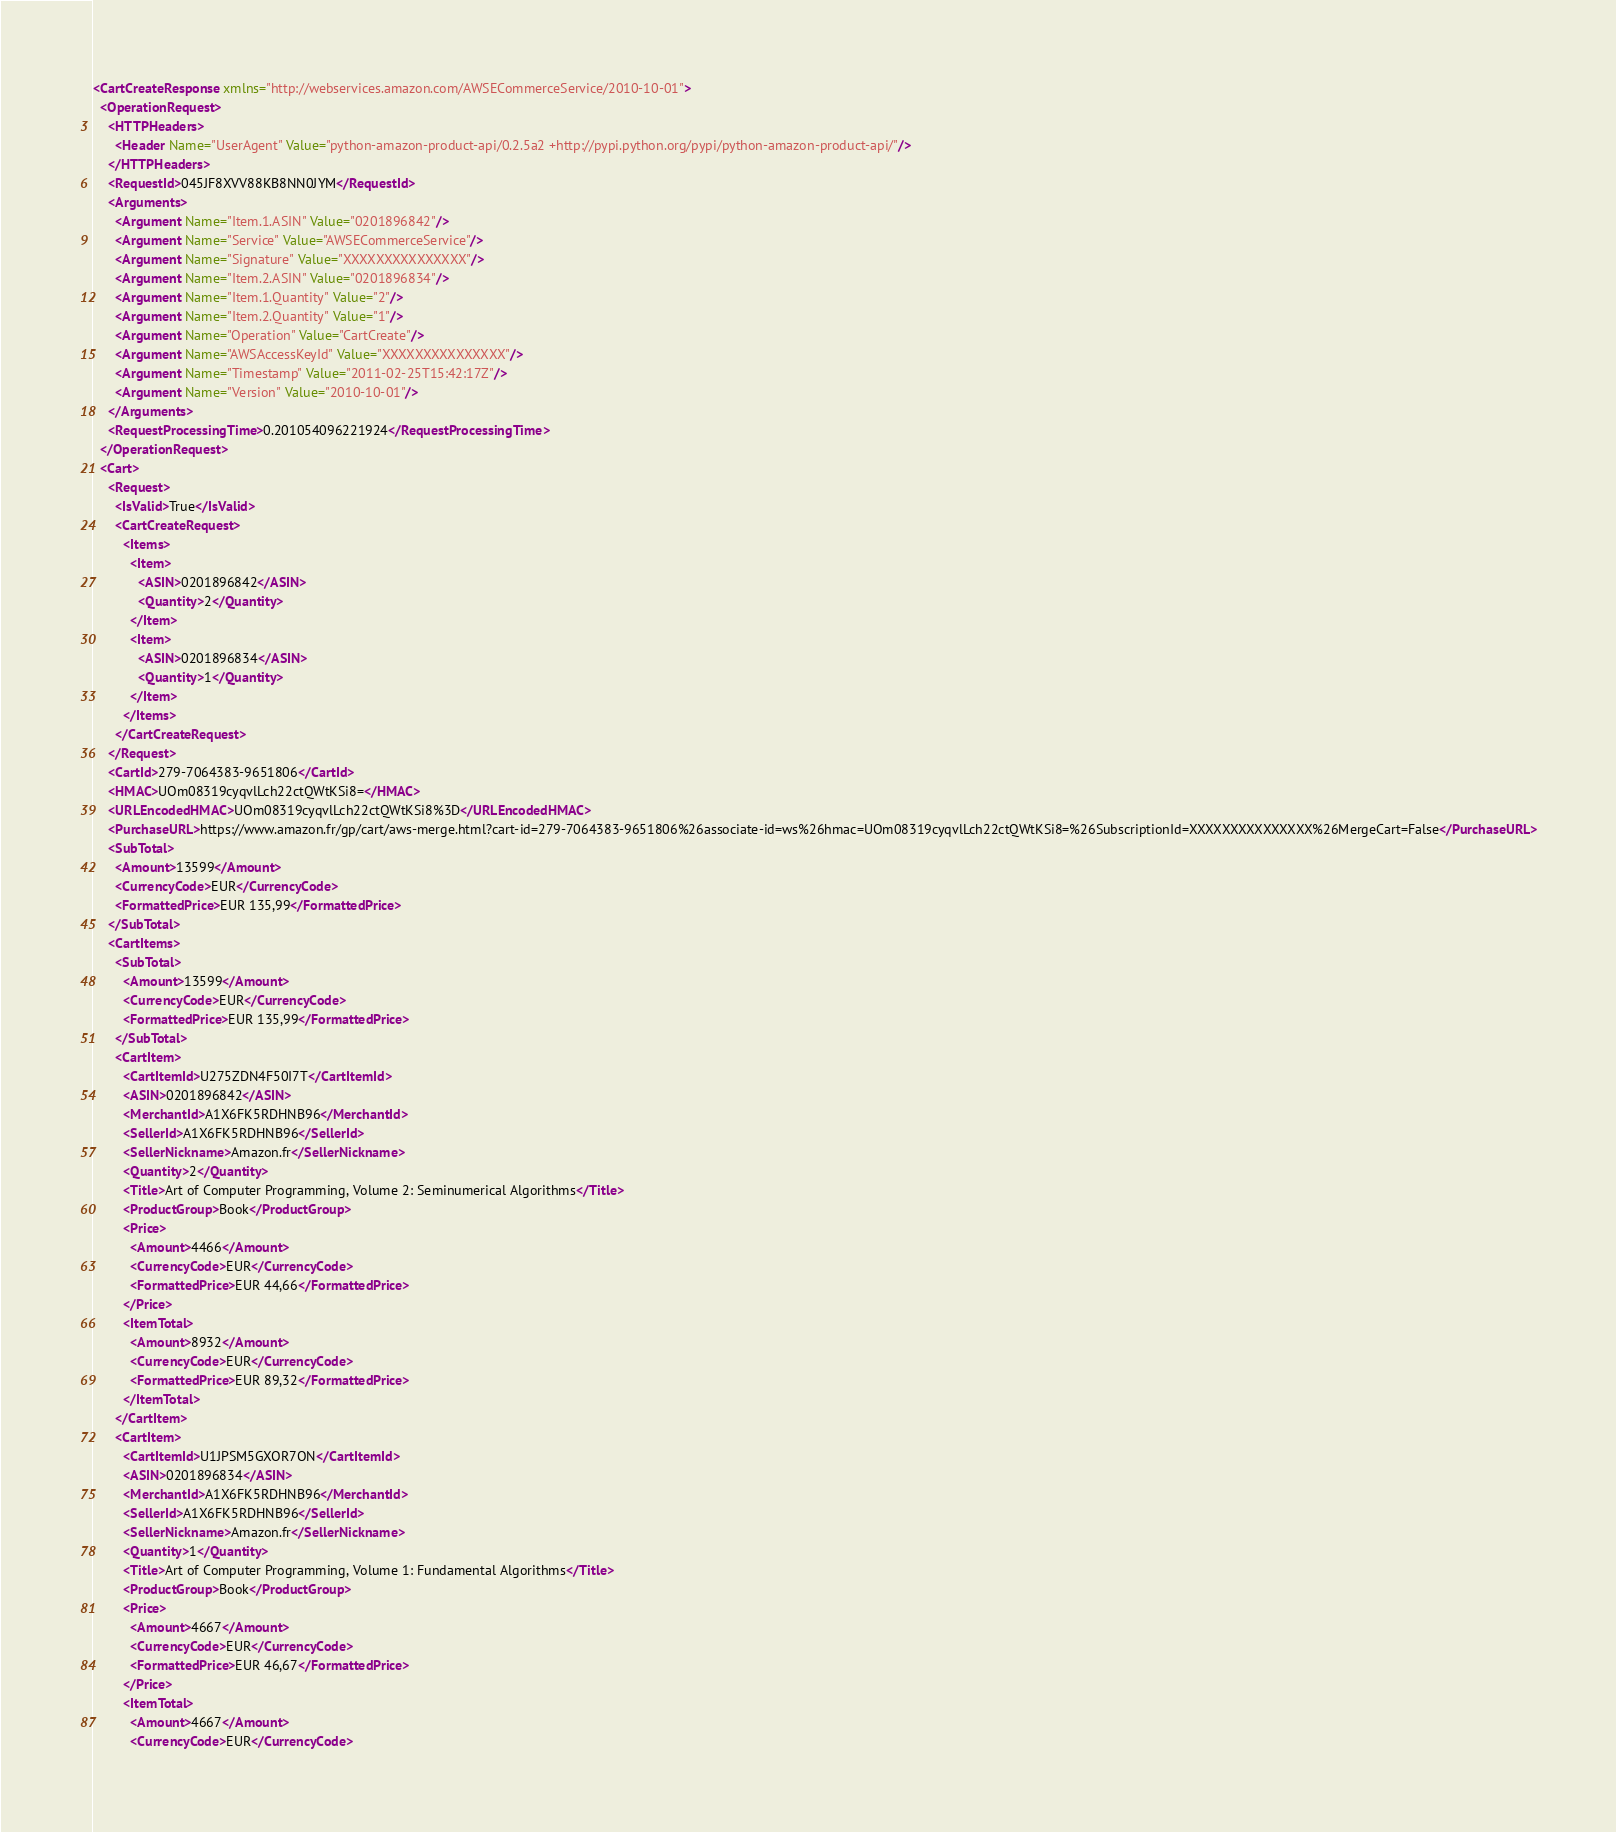Convert code to text. <code><loc_0><loc_0><loc_500><loc_500><_XML_><CartCreateResponse xmlns="http://webservices.amazon.com/AWSECommerceService/2010-10-01">
  <OperationRequest>
    <HTTPHeaders>
      <Header Name="UserAgent" Value="python-amazon-product-api/0.2.5a2 +http://pypi.python.org/pypi/python-amazon-product-api/"/>
    </HTTPHeaders>
    <RequestId>045JF8XVV88KB8NN0JYM</RequestId>
    <Arguments>
      <Argument Name="Item.1.ASIN" Value="0201896842"/>
      <Argument Name="Service" Value="AWSECommerceService"/>
      <Argument Name="Signature" Value="XXXXXXXXXXXXXXX"/>
      <Argument Name="Item.2.ASIN" Value="0201896834"/>
      <Argument Name="Item.1.Quantity" Value="2"/>
      <Argument Name="Item.2.Quantity" Value="1"/>
      <Argument Name="Operation" Value="CartCreate"/>
      <Argument Name="AWSAccessKeyId" Value="XXXXXXXXXXXXXXX"/>
      <Argument Name="Timestamp" Value="2011-02-25T15:42:17Z"/>
      <Argument Name="Version" Value="2010-10-01"/>
    </Arguments>
    <RequestProcessingTime>0.201054096221924</RequestProcessingTime>
  </OperationRequest>
  <Cart>
    <Request>
      <IsValid>True</IsValid>
      <CartCreateRequest>
        <Items>
          <Item>
            <ASIN>0201896842</ASIN>
            <Quantity>2</Quantity>
          </Item>
          <Item>
            <ASIN>0201896834</ASIN>
            <Quantity>1</Quantity>
          </Item>
        </Items>
      </CartCreateRequest>
    </Request>
    <CartId>279-7064383-9651806</CartId>
    <HMAC>UOm08319cyqvlLch22ctQWtKSi8=</HMAC>
    <URLEncodedHMAC>UOm08319cyqvlLch22ctQWtKSi8%3D</URLEncodedHMAC>
    <PurchaseURL>https://www.amazon.fr/gp/cart/aws-merge.html?cart-id=279-7064383-9651806%26associate-id=ws%26hmac=UOm08319cyqvlLch22ctQWtKSi8=%26SubscriptionId=XXXXXXXXXXXXXXX%26MergeCart=False</PurchaseURL>
    <SubTotal>
      <Amount>13599</Amount>
      <CurrencyCode>EUR</CurrencyCode>
      <FormattedPrice>EUR 135,99</FormattedPrice>
    </SubTotal>
    <CartItems>
      <SubTotal>
        <Amount>13599</Amount>
        <CurrencyCode>EUR</CurrencyCode>
        <FormattedPrice>EUR 135,99</FormattedPrice>
      </SubTotal>
      <CartItem>
        <CartItemId>U275ZDN4F50I7T</CartItemId>
        <ASIN>0201896842</ASIN>
        <MerchantId>A1X6FK5RDHNB96</MerchantId>
        <SellerId>A1X6FK5RDHNB96</SellerId>
        <SellerNickname>Amazon.fr</SellerNickname>
        <Quantity>2</Quantity>
        <Title>Art of Computer Programming, Volume 2: Seminumerical Algorithms</Title>
        <ProductGroup>Book</ProductGroup>
        <Price>
          <Amount>4466</Amount>
          <CurrencyCode>EUR</CurrencyCode>
          <FormattedPrice>EUR 44,66</FormattedPrice>
        </Price>
        <ItemTotal>
          <Amount>8932</Amount>
          <CurrencyCode>EUR</CurrencyCode>
          <FormattedPrice>EUR 89,32</FormattedPrice>
        </ItemTotal>
      </CartItem>
      <CartItem>
        <CartItemId>U1JPSM5GXOR7ON</CartItemId>
        <ASIN>0201896834</ASIN>
        <MerchantId>A1X6FK5RDHNB96</MerchantId>
        <SellerId>A1X6FK5RDHNB96</SellerId>
        <SellerNickname>Amazon.fr</SellerNickname>
        <Quantity>1</Quantity>
        <Title>Art of Computer Programming, Volume 1: Fundamental Algorithms</Title>
        <ProductGroup>Book</ProductGroup>
        <Price>
          <Amount>4667</Amount>
          <CurrencyCode>EUR</CurrencyCode>
          <FormattedPrice>EUR 46,67</FormattedPrice>
        </Price>
        <ItemTotal>
          <Amount>4667</Amount>
          <CurrencyCode>EUR</CurrencyCode></code> 